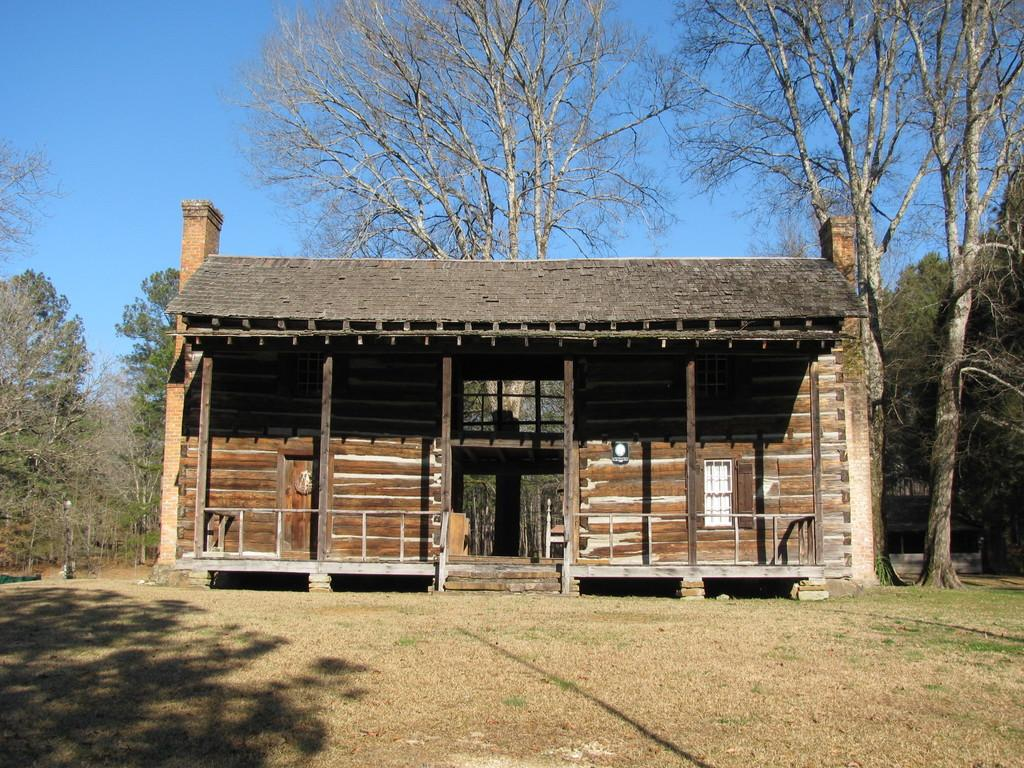What type of surface can be seen in the image? There is ground visible in the image. What type of vegetation is present in the image? There is grass in the image. Can you describe the house in the image? The house in the image is brown, white, and grey. What other natural elements can be seen in the image? There are trees in the image. What is visible in the background of the image? The background of the image includes trees, and the sky is visible. How many pizzas are being rolled on the grass in the image? There are no pizzas present in the image, and therefore no rolling can be observed. 